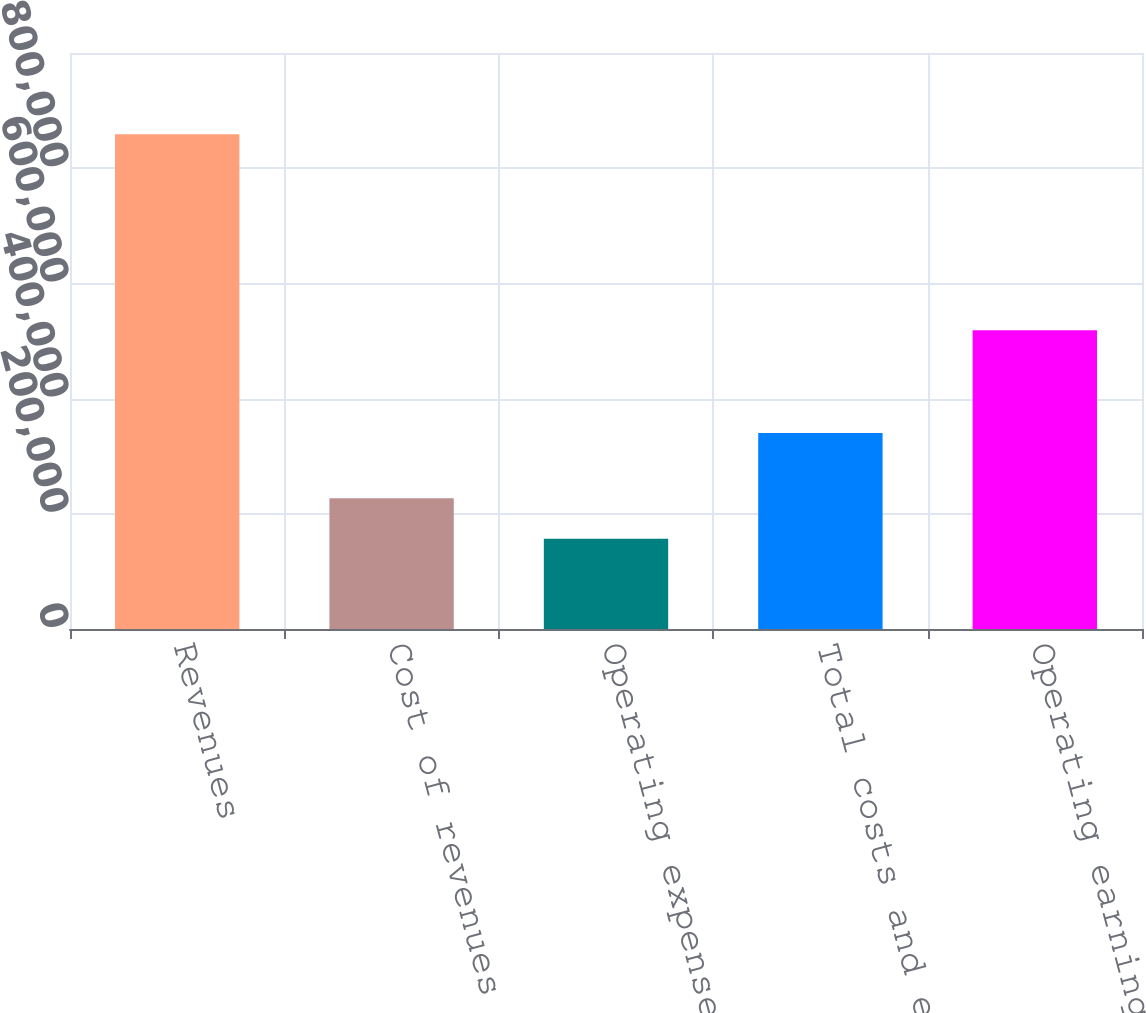Convert chart. <chart><loc_0><loc_0><loc_500><loc_500><bar_chart><fcel>Revenues<fcel>Cost of revenues<fcel>Operating expenses<fcel>Total costs and expenses<fcel>Operating earnings<nl><fcel>858945<fcel>227094<fcel>156888<fcel>340154<fcel>518791<nl></chart> 